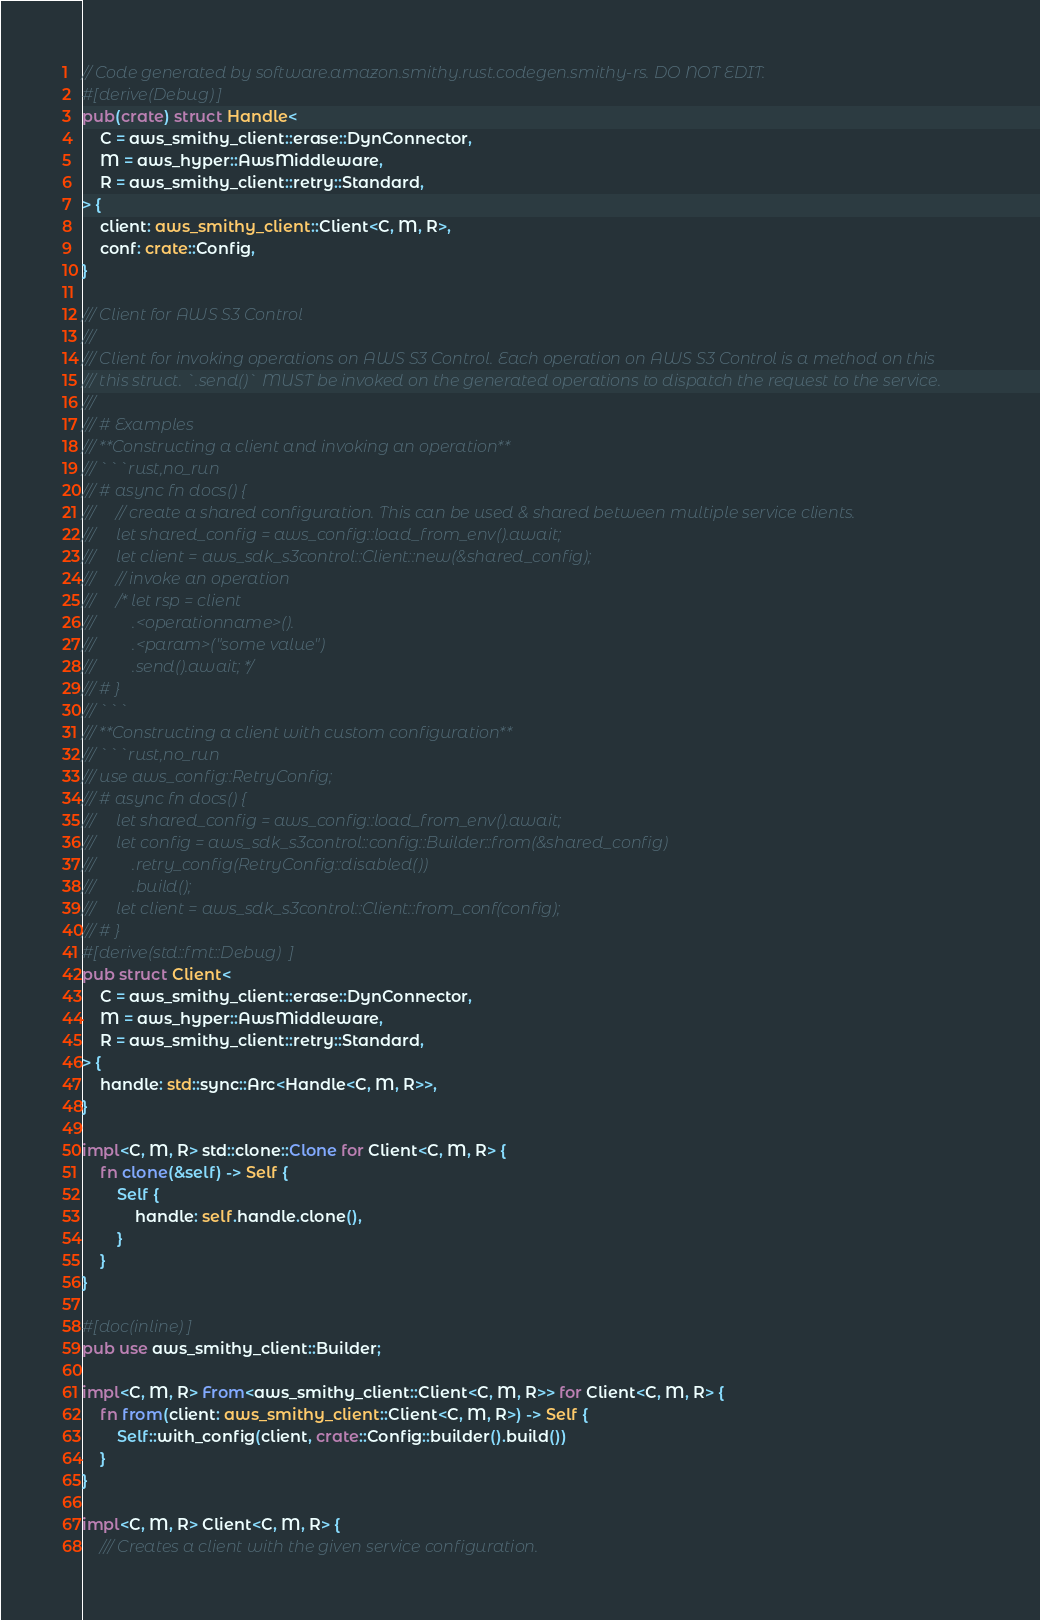Convert code to text. <code><loc_0><loc_0><loc_500><loc_500><_Rust_>// Code generated by software.amazon.smithy.rust.codegen.smithy-rs. DO NOT EDIT.
#[derive(Debug)]
pub(crate) struct Handle<
    C = aws_smithy_client::erase::DynConnector,
    M = aws_hyper::AwsMiddleware,
    R = aws_smithy_client::retry::Standard,
> {
    client: aws_smithy_client::Client<C, M, R>,
    conf: crate::Config,
}

/// Client for AWS S3 Control
///
/// Client for invoking operations on AWS S3 Control. Each operation on AWS S3 Control is a method on this
/// this struct. `.send()` MUST be invoked on the generated operations to dispatch the request to the service.
///
/// # Examples
/// **Constructing a client and invoking an operation**
/// ```rust,no_run
/// # async fn docs() {
///     // create a shared configuration. This can be used & shared between multiple service clients.
///     let shared_config = aws_config::load_from_env().await;
///     let client = aws_sdk_s3control::Client::new(&shared_config);
///     // invoke an operation
///     /* let rsp = client
///         .<operationname>().
///         .<param>("some value")
///         .send().await; */
/// # }
/// ```
/// **Constructing a client with custom configuration**
/// ```rust,no_run
/// use aws_config::RetryConfig;
/// # async fn docs() {
///     let shared_config = aws_config::load_from_env().await;
///     let config = aws_sdk_s3control::config::Builder::from(&shared_config)
///         .retry_config(RetryConfig::disabled())
///         .build();
///     let client = aws_sdk_s3control::Client::from_conf(config);
/// # }
#[derive(std::fmt::Debug)]
pub struct Client<
    C = aws_smithy_client::erase::DynConnector,
    M = aws_hyper::AwsMiddleware,
    R = aws_smithy_client::retry::Standard,
> {
    handle: std::sync::Arc<Handle<C, M, R>>,
}

impl<C, M, R> std::clone::Clone for Client<C, M, R> {
    fn clone(&self) -> Self {
        Self {
            handle: self.handle.clone(),
        }
    }
}

#[doc(inline)]
pub use aws_smithy_client::Builder;

impl<C, M, R> From<aws_smithy_client::Client<C, M, R>> for Client<C, M, R> {
    fn from(client: aws_smithy_client::Client<C, M, R>) -> Self {
        Self::with_config(client, crate::Config::builder().build())
    }
}

impl<C, M, R> Client<C, M, R> {
    /// Creates a client with the given service configuration.</code> 